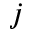<formula> <loc_0><loc_0><loc_500><loc_500>j</formula> 